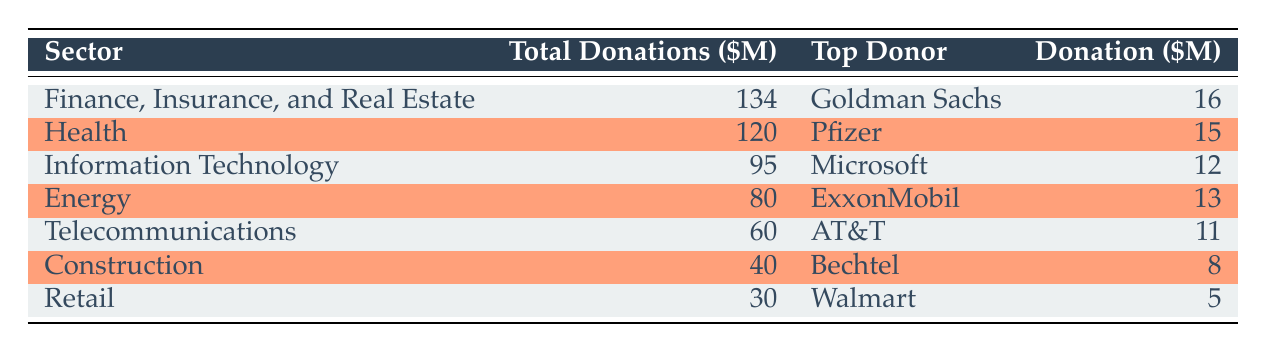What is the total amount of donations from the Finance, Insurance, and Real Estate sector? The table indicates that the total donations from the Finance, Insurance, and Real Estate sector are listed in the second column. The value is 134 million dollars.
Answer: 134 million dollars Which sector received the least amount of total donations? By examining the total donations in the second column, the sector with the least amount is Retail, with total donations of 30 million dollars.
Answer: Retail Who was the top donor in the Health sector and how much did they donate? The top donor for the Health sector is identified in the third column of the corresponding row. The donor is Pfizer, and they contributed 15 million dollars.
Answer: Pfizer, 15 million dollars What is the difference in total donations between the Information Technology and Energy sectors? First, find the total donations for Information Technology (95 million) and Energy (80 million). The difference is 95 million - 80 million = 15 million.
Answer: 15 million Is it true that Walmart was the top donor in the Retail sector? By looking at the table, Walmart is listed as the top donor in the Retail sector. Therefore, the statement is true.
Answer: Yes What is the average total donation amount across all sectors listed in the table? To calculate the average, add the total donations (134 + 120 + 95 + 80 + 60 + 40 + 30 = 559 million) and divide by the number of sectors (7). So, the average is 559/7 ≈ 79.857 million.
Answer: Approximately 79.857 million Which sector has a higher total donation: Health or Energy? By comparing the total donations in the table, Health has 120 million and Energy has 80 million. Therefore, Health has a higher total donation.
Answer: Health How much more did Goldman Sachs donate than AT&T? Goldman Sachs donated 16 million while AT&T donated 11 million. The difference is 16 million - 11 million = 5 million.
Answer: 5 million 